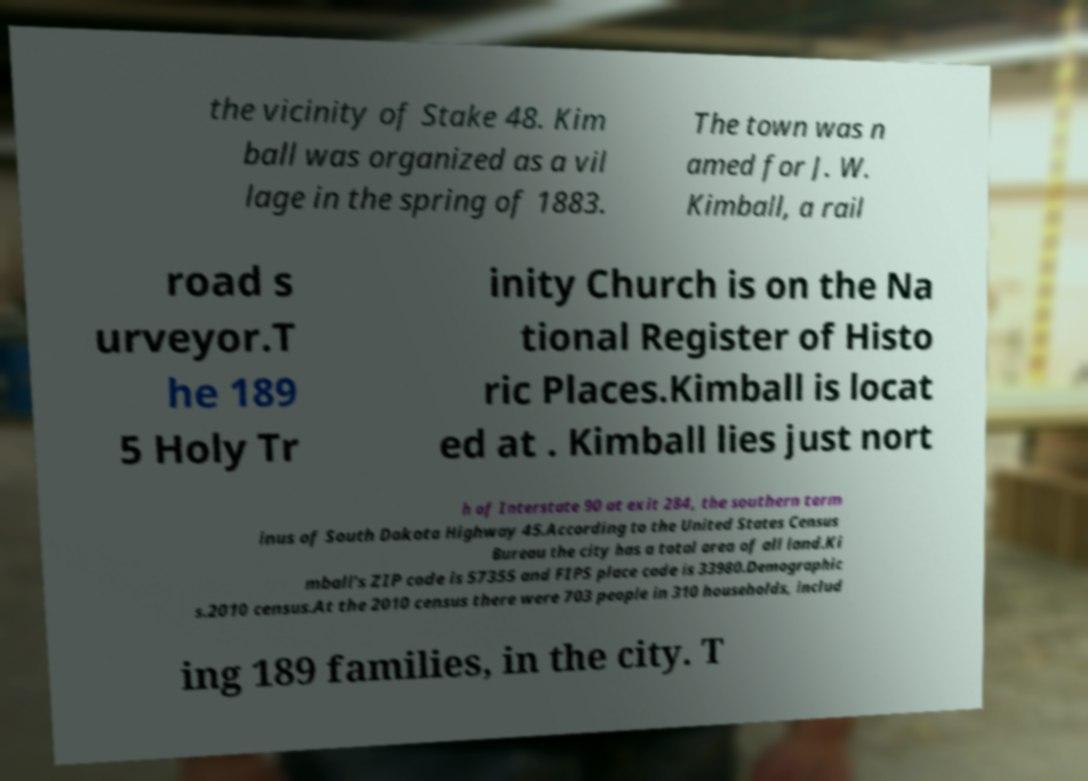Please identify and transcribe the text found in this image. the vicinity of Stake 48. Kim ball was organized as a vil lage in the spring of 1883. The town was n amed for J. W. Kimball, a rail road s urveyor.T he 189 5 Holy Tr inity Church is on the Na tional Register of Histo ric Places.Kimball is locat ed at . Kimball lies just nort h of Interstate 90 at exit 284, the southern term inus of South Dakota Highway 45.According to the United States Census Bureau the city has a total area of all land.Ki mball's ZIP code is 57355 and FIPS place code is 33980.Demographic s.2010 census.At the 2010 census there were 703 people in 310 households, includ ing 189 families, in the city. T 